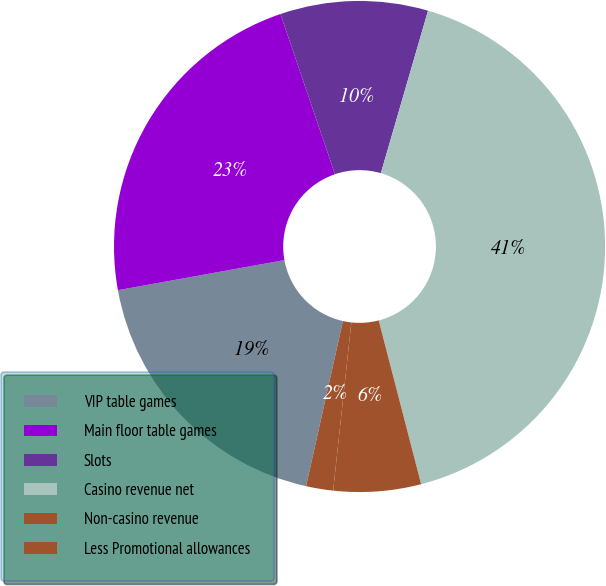Convert chart to OTSL. <chart><loc_0><loc_0><loc_500><loc_500><pie_chart><fcel>VIP table games<fcel>Main floor table games<fcel>Slots<fcel>Casino revenue net<fcel>Non-casino revenue<fcel>Less Promotional allowances<nl><fcel>18.66%<fcel>22.63%<fcel>9.72%<fcel>41.47%<fcel>5.75%<fcel>1.78%<nl></chart> 